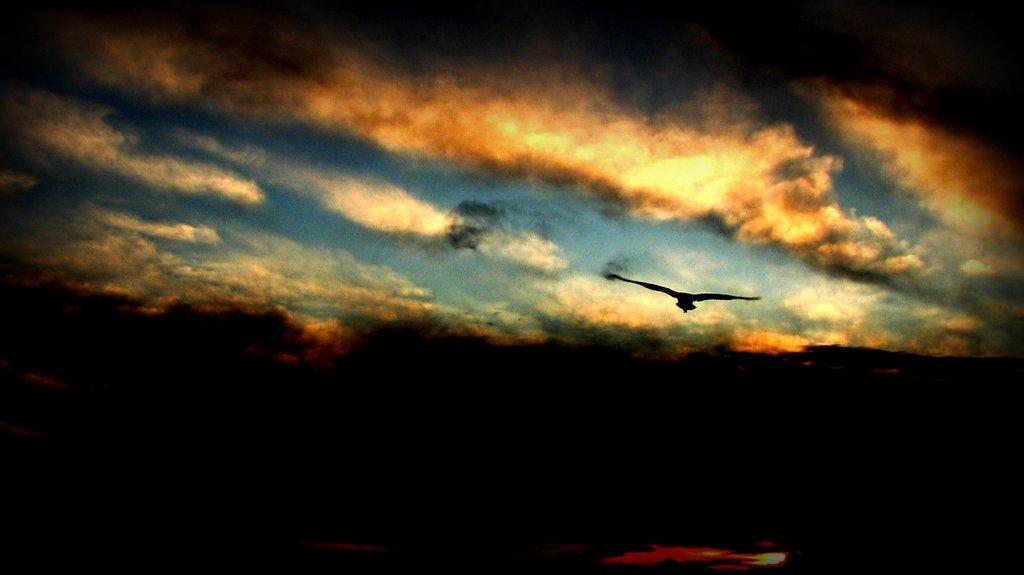What type of animal is present in the image? There is a bird in the image. What is the bird doing in the image? The bird is flying in the air. What can be seen in the background of the image? The sky is visible in the background of the image. How would you describe the lighting in the image? The image appears to be slightly dark. What type of seed is the bird eating for breakfast in the image? There is no seed or reference to breakfast in the image; it simply shows a bird flying in the air. 